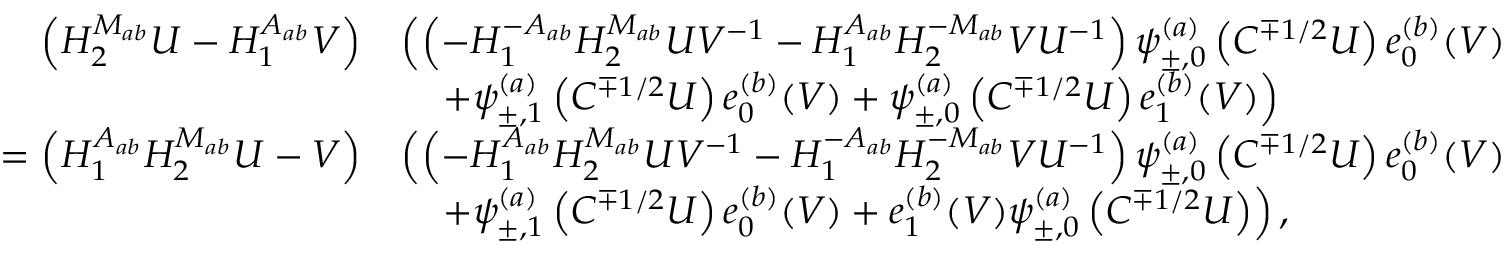<formula> <loc_0><loc_0><loc_500><loc_500>\begin{array} { r l } { \quad \left ( H _ { 2 } ^ { M _ { a b } } U - H _ { 1 } ^ { A _ { a b } } V \right ) } & { \left ( \left ( - H _ { 1 } ^ { - A _ { a b } } H _ { 2 } ^ { M _ { a b } } U V ^ { - 1 } - H _ { 1 } ^ { A _ { a b } } H _ { 2 } ^ { - M _ { a b } } V U ^ { - 1 } \right ) \psi _ { \pm , 0 } ^ { ( a ) } \left ( C ^ { \mp 1 / 2 } U \right ) e _ { 0 } ^ { ( b ) } ( V ) } \\ & { \quad + \psi _ { \pm , 1 } ^ { ( a ) } \left ( C ^ { \mp 1 / 2 } U \right ) e _ { 0 } ^ { ( b ) } ( V ) + \psi _ { \pm , 0 } ^ { ( a ) } \left ( C ^ { \mp 1 / 2 } U \right ) e _ { 1 } ^ { ( b ) } ( V ) \right ) } \\ { = \left ( H _ { 1 } ^ { A _ { a b } } H _ { 2 } ^ { M _ { a b } } U - V \right ) } & { \left ( \left ( - H _ { 1 } ^ { A _ { a b } } H _ { 2 } ^ { M _ { a b } } U V ^ { - 1 } - H _ { 1 } ^ { - A _ { a b } } H _ { 2 } ^ { - M _ { a b } } V U ^ { - 1 } \right ) \psi _ { \pm , 0 } ^ { ( a ) } \left ( C ^ { \mp 1 / 2 } U \right ) e _ { 0 } ^ { ( b ) } ( V ) } \\ & { \quad + \psi _ { \pm , 1 } ^ { ( a ) } \left ( C ^ { \mp 1 / 2 } U \right ) e _ { 0 } ^ { ( b ) } ( V ) + e _ { 1 } ^ { ( b ) } ( V ) \psi _ { \pm , 0 } ^ { ( a ) } \left ( C ^ { \mp 1 / 2 } U \right ) \right ) , } \end{array}</formula> 